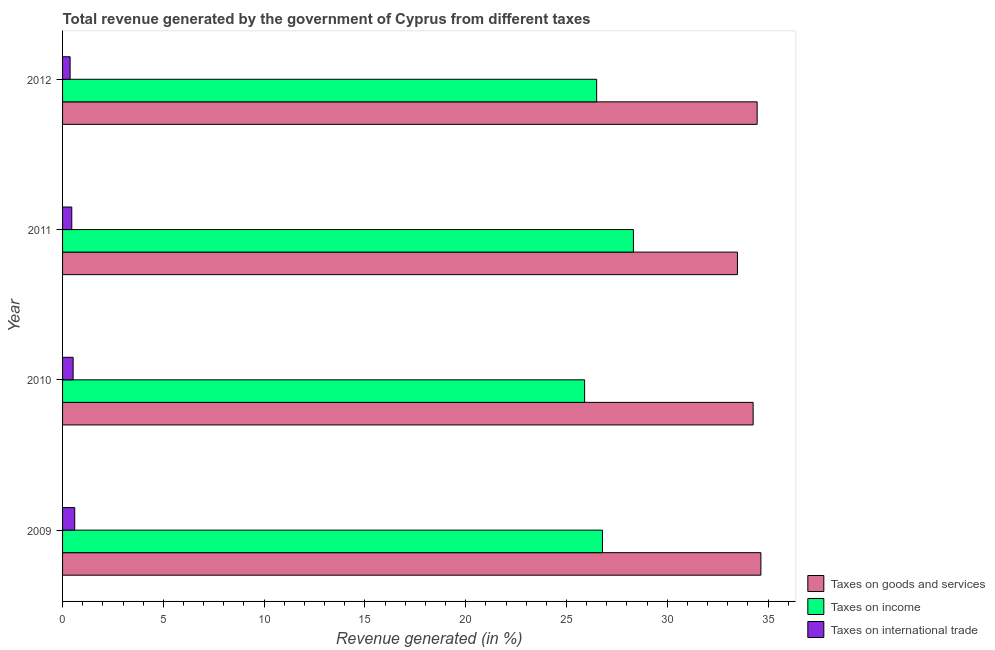How many groups of bars are there?
Your answer should be very brief. 4. Are the number of bars per tick equal to the number of legend labels?
Give a very brief answer. Yes. How many bars are there on the 4th tick from the bottom?
Ensure brevity in your answer.  3. What is the label of the 4th group of bars from the top?
Give a very brief answer. 2009. What is the percentage of revenue generated by taxes on income in 2009?
Make the answer very short. 26.78. Across all years, what is the maximum percentage of revenue generated by taxes on income?
Your response must be concise. 28.32. Across all years, what is the minimum percentage of revenue generated by tax on international trade?
Keep it short and to the point. 0.37. What is the total percentage of revenue generated by taxes on income in the graph?
Provide a short and direct response. 107.5. What is the difference between the percentage of revenue generated by taxes on goods and services in 2009 and that in 2011?
Your answer should be compact. 1.16. What is the difference between the percentage of revenue generated by tax on international trade in 2010 and the percentage of revenue generated by taxes on goods and services in 2009?
Make the answer very short. -34.12. What is the average percentage of revenue generated by taxes on goods and services per year?
Ensure brevity in your answer.  34.21. In the year 2012, what is the difference between the percentage of revenue generated by taxes on goods and services and percentage of revenue generated by tax on international trade?
Keep it short and to the point. 34.08. In how many years, is the percentage of revenue generated by taxes on goods and services greater than 9 %?
Provide a short and direct response. 4. Is the percentage of revenue generated by taxes on goods and services in 2011 less than that in 2012?
Keep it short and to the point. Yes. Is the difference between the percentage of revenue generated by tax on international trade in 2010 and 2012 greater than the difference between the percentage of revenue generated by taxes on goods and services in 2010 and 2012?
Ensure brevity in your answer.  Yes. What is the difference between the highest and the second highest percentage of revenue generated by taxes on goods and services?
Keep it short and to the point. 0.18. What is the difference between the highest and the lowest percentage of revenue generated by tax on international trade?
Your answer should be very brief. 0.23. Is the sum of the percentage of revenue generated by tax on international trade in 2010 and 2011 greater than the maximum percentage of revenue generated by taxes on goods and services across all years?
Make the answer very short. No. What does the 2nd bar from the top in 2012 represents?
Give a very brief answer. Taxes on income. What does the 1st bar from the bottom in 2012 represents?
Keep it short and to the point. Taxes on goods and services. Is it the case that in every year, the sum of the percentage of revenue generated by taxes on goods and services and percentage of revenue generated by taxes on income is greater than the percentage of revenue generated by tax on international trade?
Offer a terse response. Yes. Are all the bars in the graph horizontal?
Your answer should be compact. Yes. What is the difference between two consecutive major ticks on the X-axis?
Your answer should be compact. 5. Are the values on the major ticks of X-axis written in scientific E-notation?
Your response must be concise. No. Where does the legend appear in the graph?
Keep it short and to the point. Bottom right. What is the title of the graph?
Provide a succinct answer. Total revenue generated by the government of Cyprus from different taxes. Does "Agriculture" appear as one of the legend labels in the graph?
Your answer should be very brief. No. What is the label or title of the X-axis?
Provide a short and direct response. Revenue generated (in %). What is the Revenue generated (in %) of Taxes on goods and services in 2009?
Offer a terse response. 34.64. What is the Revenue generated (in %) of Taxes on income in 2009?
Keep it short and to the point. 26.78. What is the Revenue generated (in %) in Taxes on international trade in 2009?
Ensure brevity in your answer.  0.6. What is the Revenue generated (in %) of Taxes on goods and services in 2010?
Your answer should be compact. 34.26. What is the Revenue generated (in %) in Taxes on income in 2010?
Provide a short and direct response. 25.9. What is the Revenue generated (in %) of Taxes on international trade in 2010?
Your response must be concise. 0.52. What is the Revenue generated (in %) of Taxes on goods and services in 2011?
Your answer should be compact. 33.48. What is the Revenue generated (in %) of Taxes on income in 2011?
Provide a short and direct response. 28.32. What is the Revenue generated (in %) in Taxes on international trade in 2011?
Your answer should be compact. 0.46. What is the Revenue generated (in %) of Taxes on goods and services in 2012?
Offer a very short reply. 34.46. What is the Revenue generated (in %) in Taxes on income in 2012?
Your answer should be very brief. 26.5. What is the Revenue generated (in %) in Taxes on international trade in 2012?
Offer a very short reply. 0.37. Across all years, what is the maximum Revenue generated (in %) in Taxes on goods and services?
Your answer should be very brief. 34.64. Across all years, what is the maximum Revenue generated (in %) of Taxes on income?
Provide a short and direct response. 28.32. Across all years, what is the maximum Revenue generated (in %) in Taxes on international trade?
Offer a very short reply. 0.6. Across all years, what is the minimum Revenue generated (in %) in Taxes on goods and services?
Offer a very short reply. 33.48. Across all years, what is the minimum Revenue generated (in %) in Taxes on income?
Provide a succinct answer. 25.9. Across all years, what is the minimum Revenue generated (in %) in Taxes on international trade?
Your answer should be very brief. 0.37. What is the total Revenue generated (in %) in Taxes on goods and services in the graph?
Your answer should be compact. 136.84. What is the total Revenue generated (in %) in Taxes on income in the graph?
Your response must be concise. 107.5. What is the total Revenue generated (in %) of Taxes on international trade in the graph?
Provide a succinct answer. 1.96. What is the difference between the Revenue generated (in %) in Taxes on goods and services in 2009 and that in 2010?
Provide a short and direct response. 0.38. What is the difference between the Revenue generated (in %) in Taxes on income in 2009 and that in 2010?
Provide a short and direct response. 0.89. What is the difference between the Revenue generated (in %) of Taxes on international trade in 2009 and that in 2010?
Your answer should be compact. 0.08. What is the difference between the Revenue generated (in %) of Taxes on goods and services in 2009 and that in 2011?
Your answer should be compact. 1.16. What is the difference between the Revenue generated (in %) of Taxes on income in 2009 and that in 2011?
Offer a terse response. -1.54. What is the difference between the Revenue generated (in %) in Taxes on international trade in 2009 and that in 2011?
Provide a short and direct response. 0.15. What is the difference between the Revenue generated (in %) of Taxes on goods and services in 2009 and that in 2012?
Give a very brief answer. 0.19. What is the difference between the Revenue generated (in %) in Taxes on income in 2009 and that in 2012?
Your response must be concise. 0.29. What is the difference between the Revenue generated (in %) in Taxes on international trade in 2009 and that in 2012?
Provide a short and direct response. 0.23. What is the difference between the Revenue generated (in %) in Taxes on goods and services in 2010 and that in 2011?
Give a very brief answer. 0.78. What is the difference between the Revenue generated (in %) of Taxes on income in 2010 and that in 2011?
Your response must be concise. -2.42. What is the difference between the Revenue generated (in %) in Taxes on international trade in 2010 and that in 2011?
Give a very brief answer. 0.07. What is the difference between the Revenue generated (in %) in Taxes on goods and services in 2010 and that in 2012?
Ensure brevity in your answer.  -0.2. What is the difference between the Revenue generated (in %) in Taxes on income in 2010 and that in 2012?
Your answer should be very brief. -0.6. What is the difference between the Revenue generated (in %) in Taxes on international trade in 2010 and that in 2012?
Provide a short and direct response. 0.15. What is the difference between the Revenue generated (in %) of Taxes on goods and services in 2011 and that in 2012?
Ensure brevity in your answer.  -0.98. What is the difference between the Revenue generated (in %) of Taxes on income in 2011 and that in 2012?
Offer a very short reply. 1.82. What is the difference between the Revenue generated (in %) of Taxes on international trade in 2011 and that in 2012?
Ensure brevity in your answer.  0.08. What is the difference between the Revenue generated (in %) of Taxes on goods and services in 2009 and the Revenue generated (in %) of Taxes on income in 2010?
Give a very brief answer. 8.75. What is the difference between the Revenue generated (in %) of Taxes on goods and services in 2009 and the Revenue generated (in %) of Taxes on international trade in 2010?
Ensure brevity in your answer.  34.12. What is the difference between the Revenue generated (in %) in Taxes on income in 2009 and the Revenue generated (in %) in Taxes on international trade in 2010?
Keep it short and to the point. 26.26. What is the difference between the Revenue generated (in %) of Taxes on goods and services in 2009 and the Revenue generated (in %) of Taxes on income in 2011?
Your answer should be compact. 6.32. What is the difference between the Revenue generated (in %) in Taxes on goods and services in 2009 and the Revenue generated (in %) in Taxes on international trade in 2011?
Offer a terse response. 34.19. What is the difference between the Revenue generated (in %) of Taxes on income in 2009 and the Revenue generated (in %) of Taxes on international trade in 2011?
Your answer should be very brief. 26.33. What is the difference between the Revenue generated (in %) in Taxes on goods and services in 2009 and the Revenue generated (in %) in Taxes on income in 2012?
Provide a short and direct response. 8.15. What is the difference between the Revenue generated (in %) in Taxes on goods and services in 2009 and the Revenue generated (in %) in Taxes on international trade in 2012?
Keep it short and to the point. 34.27. What is the difference between the Revenue generated (in %) of Taxes on income in 2009 and the Revenue generated (in %) of Taxes on international trade in 2012?
Provide a short and direct response. 26.41. What is the difference between the Revenue generated (in %) of Taxes on goods and services in 2010 and the Revenue generated (in %) of Taxes on income in 2011?
Make the answer very short. 5.94. What is the difference between the Revenue generated (in %) of Taxes on goods and services in 2010 and the Revenue generated (in %) of Taxes on international trade in 2011?
Your response must be concise. 33.8. What is the difference between the Revenue generated (in %) of Taxes on income in 2010 and the Revenue generated (in %) of Taxes on international trade in 2011?
Your response must be concise. 25.44. What is the difference between the Revenue generated (in %) of Taxes on goods and services in 2010 and the Revenue generated (in %) of Taxes on income in 2012?
Ensure brevity in your answer.  7.76. What is the difference between the Revenue generated (in %) in Taxes on goods and services in 2010 and the Revenue generated (in %) in Taxes on international trade in 2012?
Provide a succinct answer. 33.88. What is the difference between the Revenue generated (in %) of Taxes on income in 2010 and the Revenue generated (in %) of Taxes on international trade in 2012?
Offer a terse response. 25.52. What is the difference between the Revenue generated (in %) of Taxes on goods and services in 2011 and the Revenue generated (in %) of Taxes on income in 2012?
Your answer should be very brief. 6.98. What is the difference between the Revenue generated (in %) in Taxes on goods and services in 2011 and the Revenue generated (in %) in Taxes on international trade in 2012?
Provide a succinct answer. 33.11. What is the difference between the Revenue generated (in %) of Taxes on income in 2011 and the Revenue generated (in %) of Taxes on international trade in 2012?
Offer a terse response. 27.95. What is the average Revenue generated (in %) of Taxes on goods and services per year?
Provide a succinct answer. 34.21. What is the average Revenue generated (in %) in Taxes on income per year?
Keep it short and to the point. 26.87. What is the average Revenue generated (in %) in Taxes on international trade per year?
Offer a terse response. 0.49. In the year 2009, what is the difference between the Revenue generated (in %) in Taxes on goods and services and Revenue generated (in %) in Taxes on income?
Make the answer very short. 7.86. In the year 2009, what is the difference between the Revenue generated (in %) of Taxes on goods and services and Revenue generated (in %) of Taxes on international trade?
Your answer should be very brief. 34.04. In the year 2009, what is the difference between the Revenue generated (in %) of Taxes on income and Revenue generated (in %) of Taxes on international trade?
Your answer should be compact. 26.18. In the year 2010, what is the difference between the Revenue generated (in %) in Taxes on goods and services and Revenue generated (in %) in Taxes on income?
Offer a very short reply. 8.36. In the year 2010, what is the difference between the Revenue generated (in %) of Taxes on goods and services and Revenue generated (in %) of Taxes on international trade?
Provide a short and direct response. 33.73. In the year 2010, what is the difference between the Revenue generated (in %) of Taxes on income and Revenue generated (in %) of Taxes on international trade?
Offer a terse response. 25.37. In the year 2011, what is the difference between the Revenue generated (in %) of Taxes on goods and services and Revenue generated (in %) of Taxes on income?
Offer a very short reply. 5.16. In the year 2011, what is the difference between the Revenue generated (in %) of Taxes on goods and services and Revenue generated (in %) of Taxes on international trade?
Keep it short and to the point. 33.02. In the year 2011, what is the difference between the Revenue generated (in %) in Taxes on income and Revenue generated (in %) in Taxes on international trade?
Ensure brevity in your answer.  27.86. In the year 2012, what is the difference between the Revenue generated (in %) in Taxes on goods and services and Revenue generated (in %) in Taxes on income?
Offer a terse response. 7.96. In the year 2012, what is the difference between the Revenue generated (in %) in Taxes on goods and services and Revenue generated (in %) in Taxes on international trade?
Give a very brief answer. 34.08. In the year 2012, what is the difference between the Revenue generated (in %) in Taxes on income and Revenue generated (in %) in Taxes on international trade?
Keep it short and to the point. 26.12. What is the ratio of the Revenue generated (in %) of Taxes on goods and services in 2009 to that in 2010?
Ensure brevity in your answer.  1.01. What is the ratio of the Revenue generated (in %) of Taxes on income in 2009 to that in 2010?
Your answer should be very brief. 1.03. What is the ratio of the Revenue generated (in %) of Taxes on international trade in 2009 to that in 2010?
Give a very brief answer. 1.15. What is the ratio of the Revenue generated (in %) of Taxes on goods and services in 2009 to that in 2011?
Your answer should be compact. 1.03. What is the ratio of the Revenue generated (in %) of Taxes on income in 2009 to that in 2011?
Provide a succinct answer. 0.95. What is the ratio of the Revenue generated (in %) of Taxes on international trade in 2009 to that in 2011?
Make the answer very short. 1.32. What is the ratio of the Revenue generated (in %) of Taxes on goods and services in 2009 to that in 2012?
Offer a terse response. 1.01. What is the ratio of the Revenue generated (in %) in Taxes on income in 2009 to that in 2012?
Keep it short and to the point. 1.01. What is the ratio of the Revenue generated (in %) of Taxes on international trade in 2009 to that in 2012?
Give a very brief answer. 1.61. What is the ratio of the Revenue generated (in %) of Taxes on goods and services in 2010 to that in 2011?
Your response must be concise. 1.02. What is the ratio of the Revenue generated (in %) in Taxes on income in 2010 to that in 2011?
Provide a succinct answer. 0.91. What is the ratio of the Revenue generated (in %) in Taxes on international trade in 2010 to that in 2011?
Make the answer very short. 1.15. What is the ratio of the Revenue generated (in %) in Taxes on goods and services in 2010 to that in 2012?
Your answer should be compact. 0.99. What is the ratio of the Revenue generated (in %) in Taxes on income in 2010 to that in 2012?
Your answer should be compact. 0.98. What is the ratio of the Revenue generated (in %) of Taxes on international trade in 2010 to that in 2012?
Your response must be concise. 1.4. What is the ratio of the Revenue generated (in %) in Taxes on goods and services in 2011 to that in 2012?
Your answer should be compact. 0.97. What is the ratio of the Revenue generated (in %) in Taxes on income in 2011 to that in 2012?
Keep it short and to the point. 1.07. What is the ratio of the Revenue generated (in %) of Taxes on international trade in 2011 to that in 2012?
Keep it short and to the point. 1.22. What is the difference between the highest and the second highest Revenue generated (in %) of Taxes on goods and services?
Give a very brief answer. 0.19. What is the difference between the highest and the second highest Revenue generated (in %) of Taxes on income?
Keep it short and to the point. 1.54. What is the difference between the highest and the second highest Revenue generated (in %) of Taxes on international trade?
Offer a terse response. 0.08. What is the difference between the highest and the lowest Revenue generated (in %) of Taxes on goods and services?
Your answer should be compact. 1.16. What is the difference between the highest and the lowest Revenue generated (in %) of Taxes on income?
Your answer should be very brief. 2.42. What is the difference between the highest and the lowest Revenue generated (in %) of Taxes on international trade?
Offer a very short reply. 0.23. 